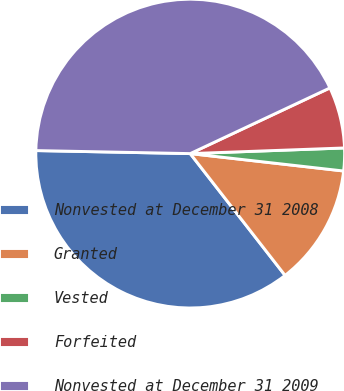Convert chart. <chart><loc_0><loc_0><loc_500><loc_500><pie_chart><fcel>Nonvested at December 31 2008<fcel>Granted<fcel>Vested<fcel>Forfeited<fcel>Nonvested at December 31 2009<nl><fcel>35.84%<fcel>12.67%<fcel>2.38%<fcel>6.41%<fcel>42.69%<nl></chart> 